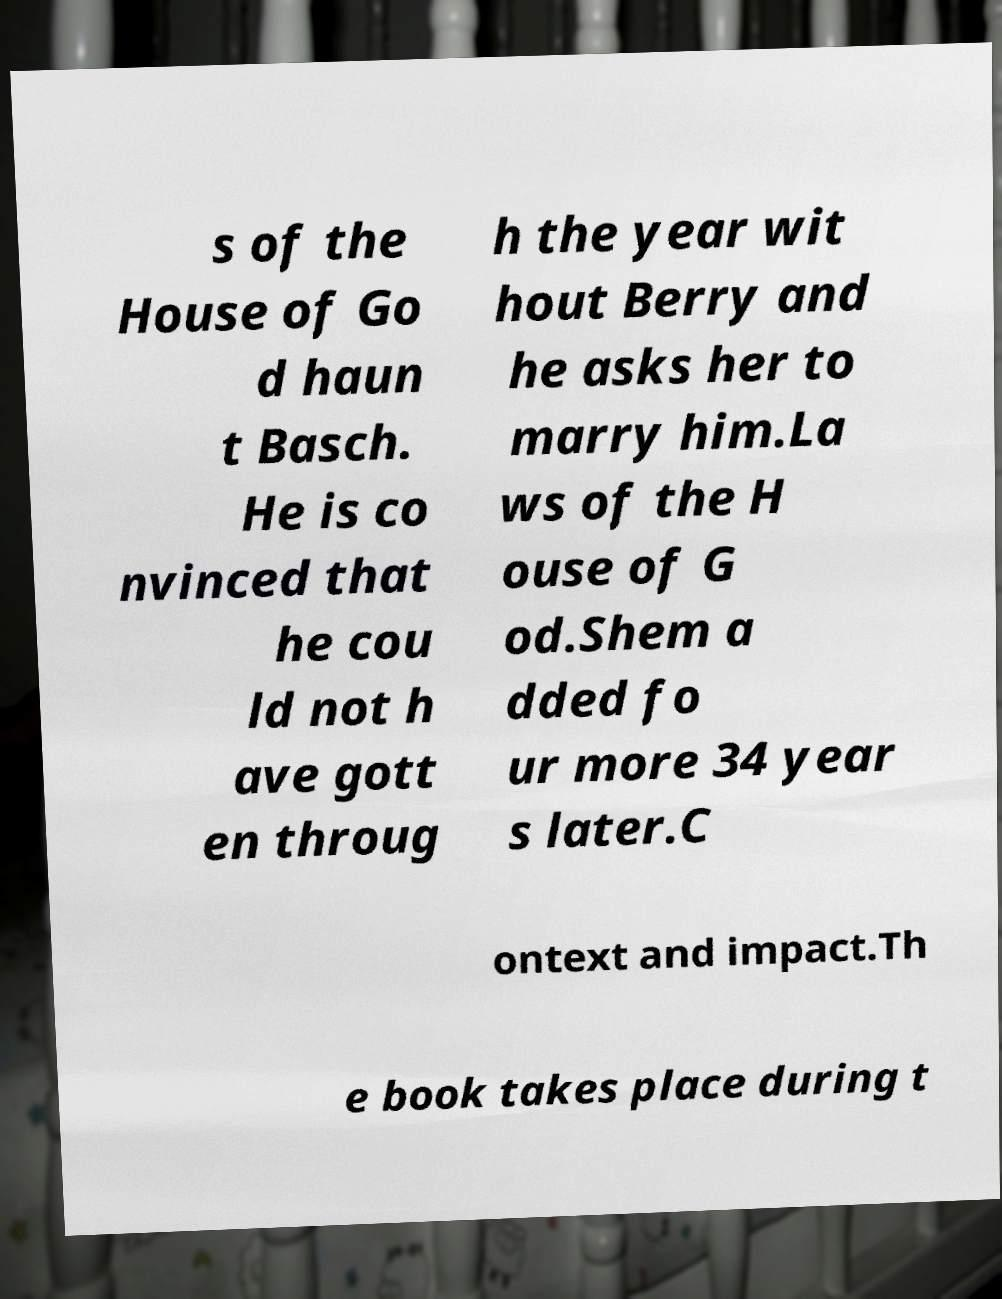Could you assist in decoding the text presented in this image and type it out clearly? s of the House of Go d haun t Basch. He is co nvinced that he cou ld not h ave gott en throug h the year wit hout Berry and he asks her to marry him.La ws of the H ouse of G od.Shem a dded fo ur more 34 year s later.C ontext and impact.Th e book takes place during t 